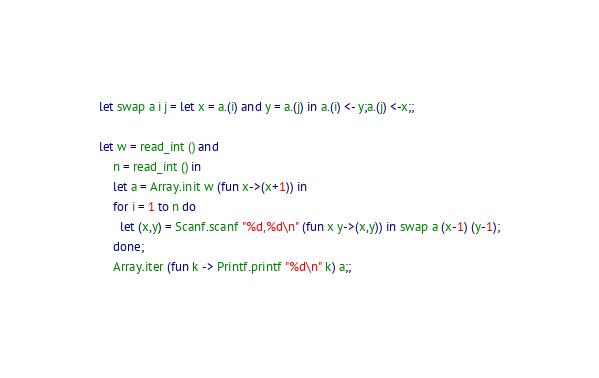Convert code to text. <code><loc_0><loc_0><loc_500><loc_500><_OCaml_>let swap a i j = let x = a.(i) and y = a.(j) in a.(i) <- y;a.(j) <-x;;

let w = read_int () and
    n = read_int () in
    let a = Array.init w (fun x->(x+1)) in
    for i = 1 to n do
      let (x,y) = Scanf.scanf "%d,%d\n" (fun x y->(x,y)) in swap a (x-1) (y-1);
    done;
    Array.iter (fun k -> Printf.printf "%d\n" k) a;;</code> 